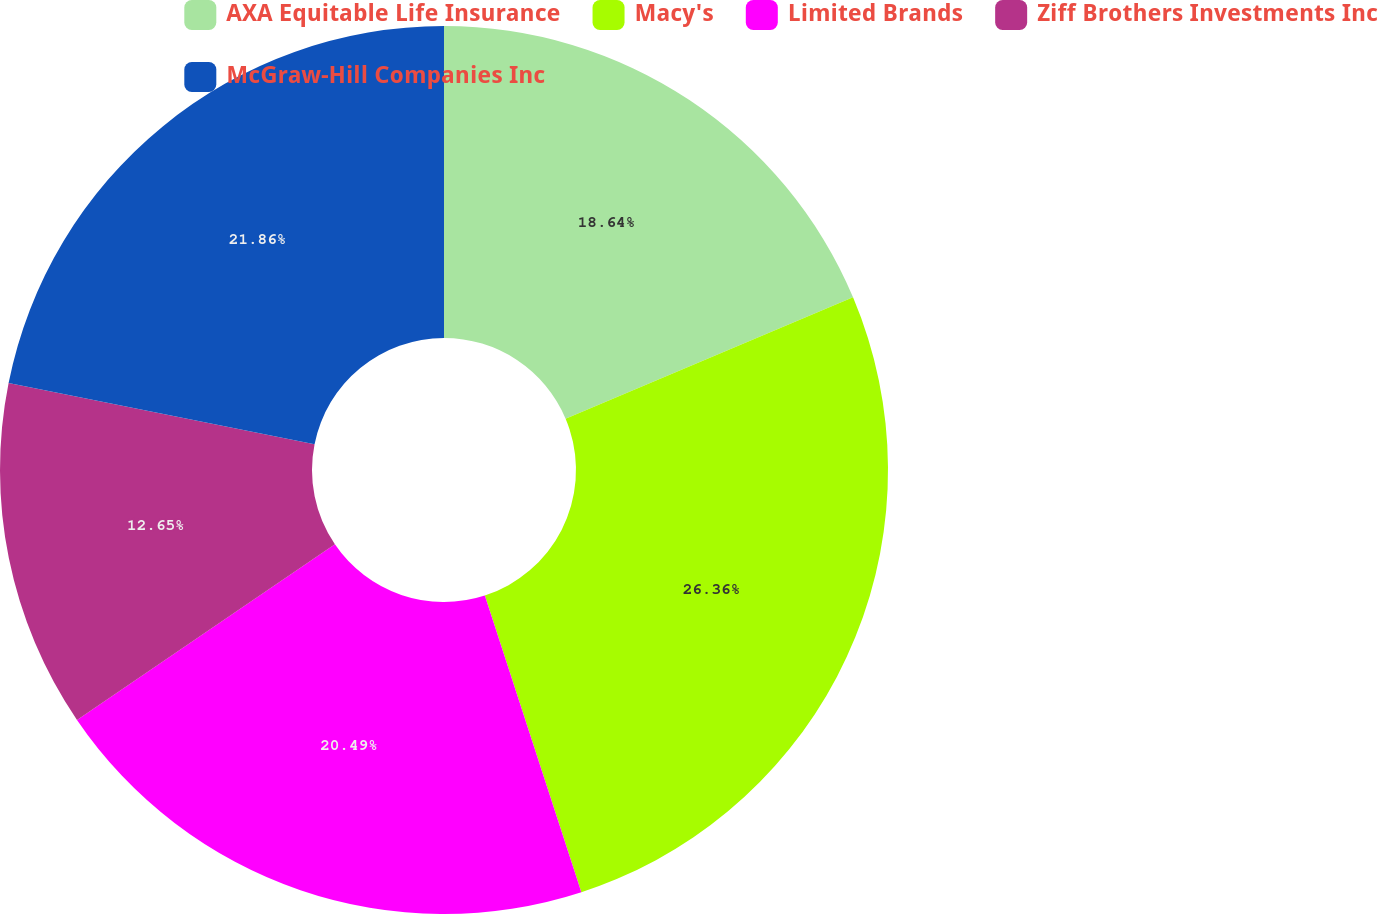Convert chart. <chart><loc_0><loc_0><loc_500><loc_500><pie_chart><fcel>AXA Equitable Life Insurance<fcel>Macy's<fcel>Limited Brands<fcel>Ziff Brothers Investments Inc<fcel>McGraw-Hill Companies Inc<nl><fcel>18.64%<fcel>26.35%<fcel>20.49%<fcel>12.65%<fcel>21.86%<nl></chart> 